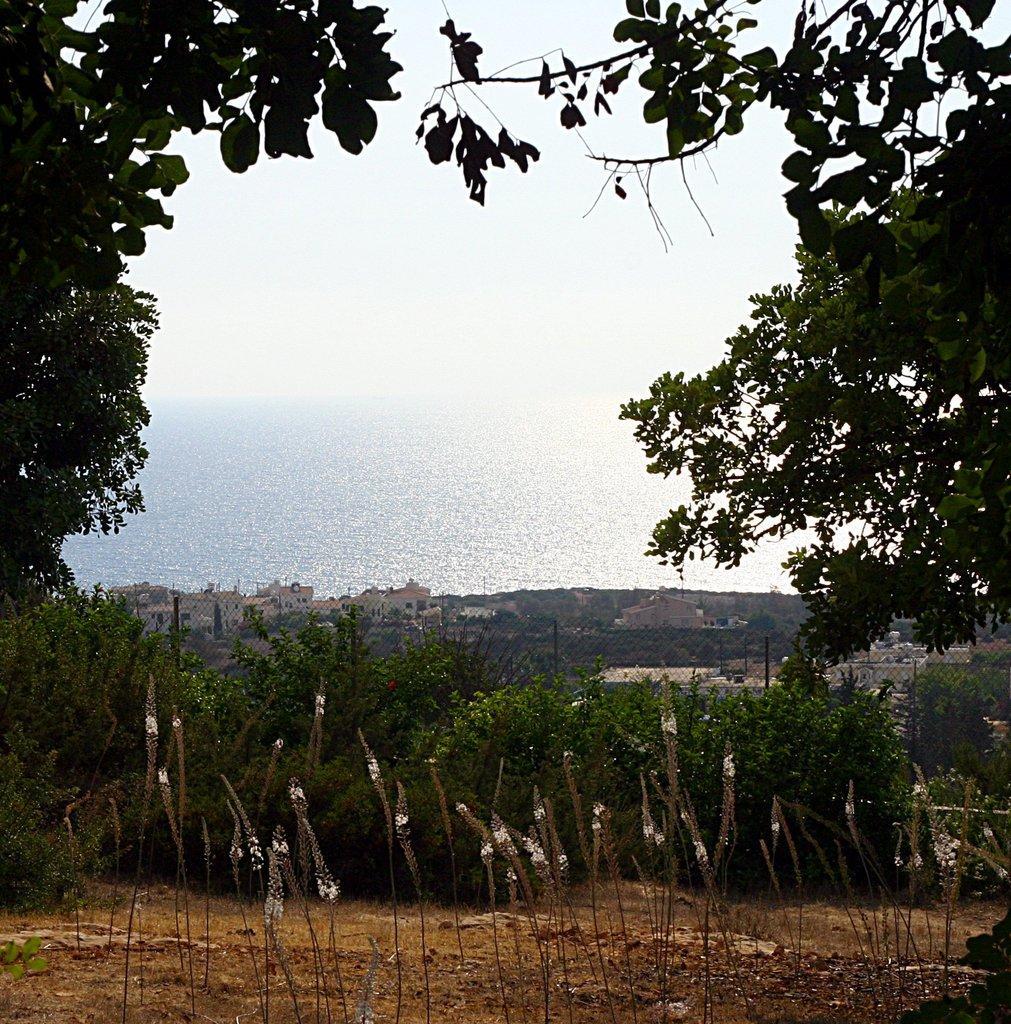Can you describe this image briefly? At the bottom of the picture there are plants and soil. On the left there are trees. On the right there are trees. In the center of the background there are buildings, fencing and a water body. Sky is sunny. 